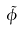Convert formula to latex. <formula><loc_0><loc_0><loc_500><loc_500>\tilde { \phi }</formula> 